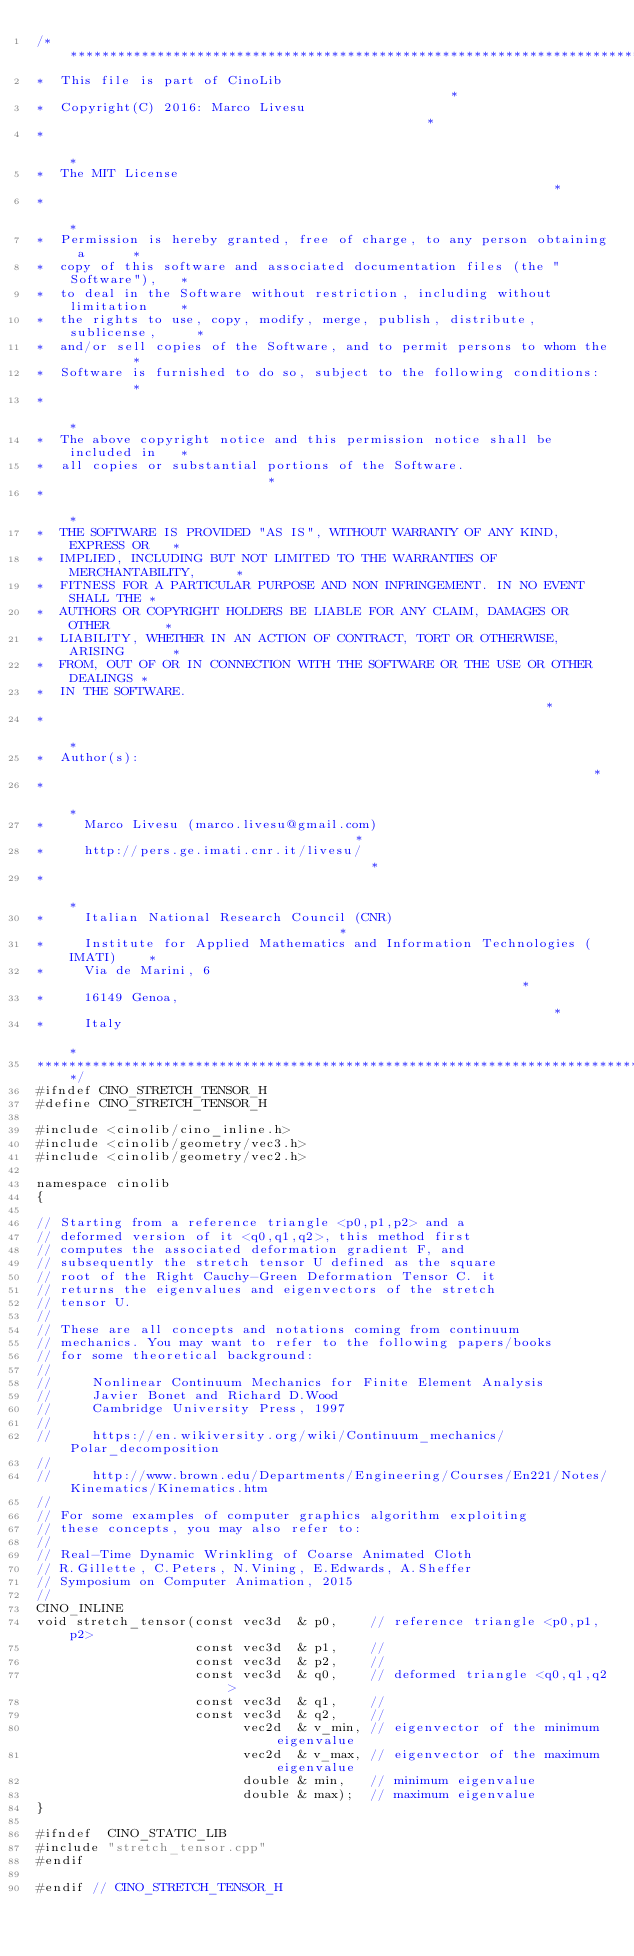<code> <loc_0><loc_0><loc_500><loc_500><_C_>/********************************************************************************
*  This file is part of CinoLib                                                 *
*  Copyright(C) 2016: Marco Livesu                                              *
*                                                                               *
*  The MIT License                                                              *
*                                                                               *
*  Permission is hereby granted, free of charge, to any person obtaining a      *
*  copy of this software and associated documentation files (the "Software"),   *
*  to deal in the Software without restriction, including without limitation    *
*  the rights to use, copy, modify, merge, publish, distribute, sublicense,     *
*  and/or sell copies of the Software, and to permit persons to whom the        *
*  Software is furnished to do so, subject to the following conditions:         *
*                                                                               *
*  The above copyright notice and this permission notice shall be included in   *
*  all copies or substantial portions of the Software.                          *
*                                                                               *
*  THE SOFTWARE IS PROVIDED "AS IS", WITHOUT WARRANTY OF ANY KIND, EXPRESS OR   *
*  IMPLIED, INCLUDING BUT NOT LIMITED TO THE WARRANTIES OF MERCHANTABILITY,     *
*  FITNESS FOR A PARTICULAR PURPOSE AND NON INFRINGEMENT. IN NO EVENT SHALL THE *
*  AUTHORS OR COPYRIGHT HOLDERS BE LIABLE FOR ANY CLAIM, DAMAGES OR OTHER       *
*  LIABILITY, WHETHER IN AN ACTION OF CONTRACT, TORT OR OTHERWISE, ARISING      *
*  FROM, OUT OF OR IN CONNECTION WITH THE SOFTWARE OR THE USE OR OTHER DEALINGS *
*  IN THE SOFTWARE.                                                             *
*                                                                               *
*  Author(s):                                                                   *
*                                                                               *
*     Marco Livesu (marco.livesu@gmail.com)                                     *
*     http://pers.ge.imati.cnr.it/livesu/                                       *
*                                                                               *
*     Italian National Research Council (CNR)                                   *
*     Institute for Applied Mathematics and Information Technologies (IMATI)    *
*     Via de Marini, 6                                                          *
*     16149 Genoa,                                                              *
*     Italy                                                                     *
*********************************************************************************/
#ifndef CINO_STRETCH_TENSOR_H
#define CINO_STRETCH_TENSOR_H

#include <cinolib/cino_inline.h>
#include <cinolib/geometry/vec3.h>
#include <cinolib/geometry/vec2.h>

namespace cinolib
{

// Starting from a reference triangle <p0,p1,p2> and a
// deformed version of it <q0,q1,q2>, this method first
// computes the associated deformation gradient F, and
// subsequently the stretch tensor U defined as the square
// root of the Right Cauchy-Green Deformation Tensor C. it
// returns the eigenvalues and eigenvectors of the stretch
// tensor U.
//
// These are all concepts and notations coming from continuum
// mechanics. You may want to refer to the following papers/books
// for some theoretical background:
//
//     Nonlinear Continuum Mechanics for Finite Element Analysis
//     Javier Bonet and Richard D.Wood
//     Cambridge University Press, 1997
//
//     https://en.wikiversity.org/wiki/Continuum_mechanics/Polar_decomposition
//
//     http://www.brown.edu/Departments/Engineering/Courses/En221/Notes/Kinematics/Kinematics.htm
//
// For some examples of computer graphics algorithm exploiting
// these concepts, you may also refer to:
//
// Real-Time Dynamic Wrinkling of Coarse Animated Cloth
// R.Gillette, C.Peters, N.Vining, E.Edwards, A.Sheffer
// Symposium on Computer Animation, 2015
//
CINO_INLINE
void stretch_tensor(const vec3d  & p0,    // reference triangle <p0,p1,p2>
                    const vec3d  & p1,    //
                    const vec3d  & p2,    //
                    const vec3d  & q0,    // deformed triangle <q0,q1,q2>
                    const vec3d  & q1,    //
                    const vec3d  & q2,    //
                          vec2d  & v_min, // eigenvector of the minimum eigenvalue
                          vec2d  & v_max, // eigenvector of the maximum eigenvalue
                          double & min,   // minimum eigenvalue
                          double & max);  // maximum eigenvalue
}

#ifndef  CINO_STATIC_LIB
#include "stretch_tensor.cpp"
#endif

#endif // CINO_STRETCH_TENSOR_H
</code> 